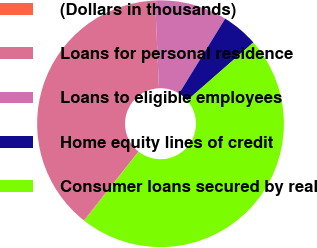Convert chart to OTSL. <chart><loc_0><loc_0><loc_500><loc_500><pie_chart><fcel>(Dollars in thousands)<fcel>Loans for personal residence<fcel>Loans to eligible employees<fcel>Home equity lines of credit<fcel>Consumer loans secured by real<nl><fcel>0.08%<fcel>38.64%<fcel>9.47%<fcel>4.78%<fcel>47.03%<nl></chart> 